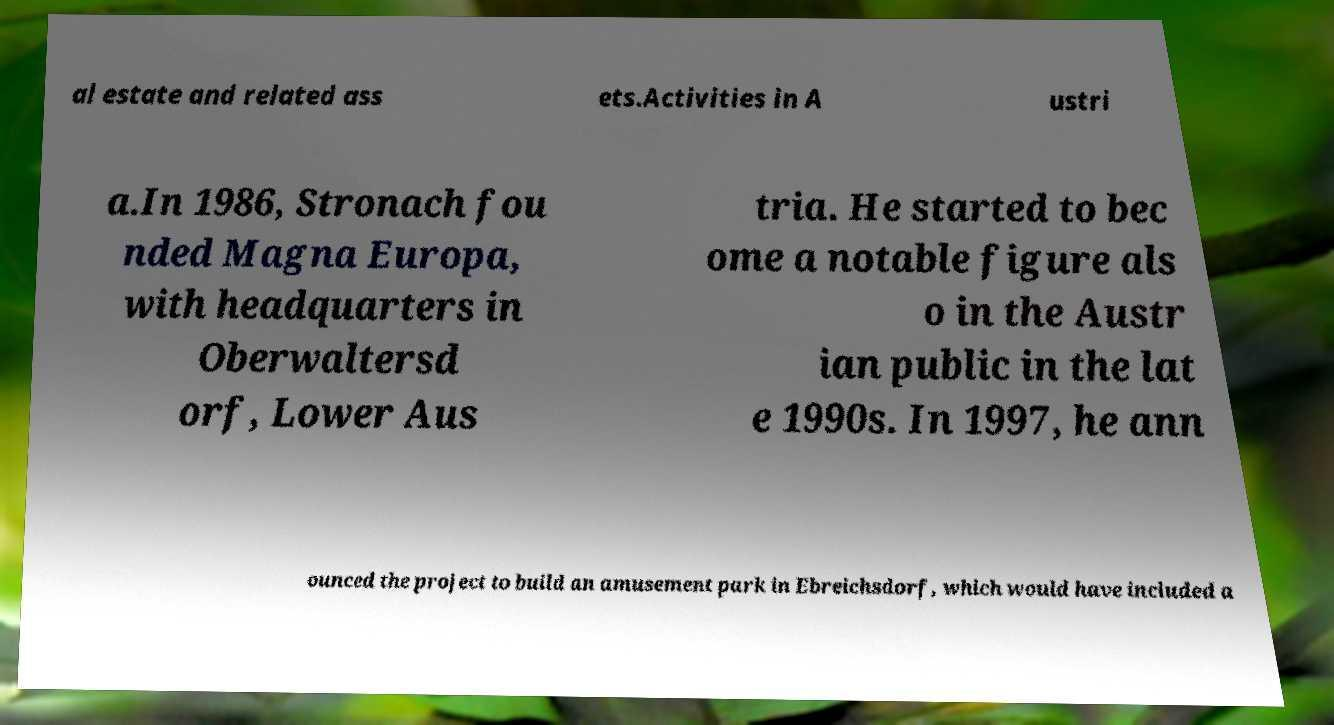Can you accurately transcribe the text from the provided image for me? al estate and related ass ets.Activities in A ustri a.In 1986, Stronach fou nded Magna Europa, with headquarters in Oberwaltersd orf, Lower Aus tria. He started to bec ome a notable figure als o in the Austr ian public in the lat e 1990s. In 1997, he ann ounced the project to build an amusement park in Ebreichsdorf, which would have included a 